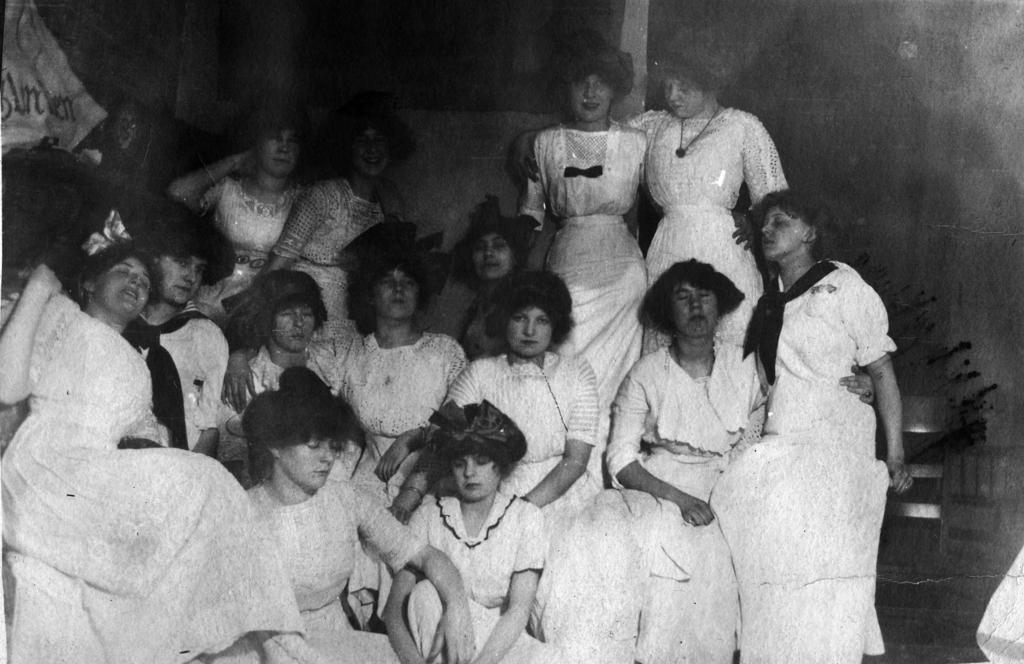What is the color scheme of the image? The image is black and white. Who is present in the image? There are women in the image. What are the women wearing? The women are wearing white dresses. What are the women doing in the image? Some women are standing, while others are sitting. Can you describe the background of the image? The background of the image is blurred. How many years does the horn in the image represent? There is no horn present in the image. What type of breath is required to see the women in the image? The image is a visual representation and does not require any specific type of breath to see the women. 